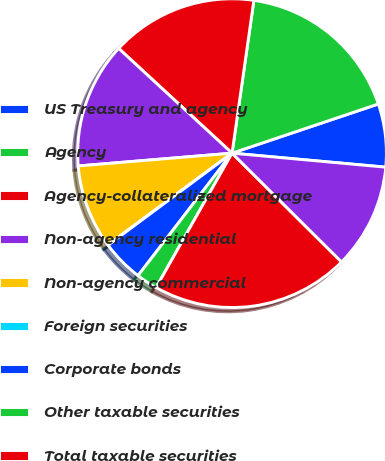<chart> <loc_0><loc_0><loc_500><loc_500><pie_chart><fcel>US Treasury and agency<fcel>Agency<fcel>Agency-collateralized mortgage<fcel>Non-agency residential<fcel>Non-agency commercial<fcel>Foreign securities<fcel>Corporate bonds<fcel>Other taxable securities<fcel>Total taxable securities<fcel>Tax-exempt securities (2)<nl><fcel>6.61%<fcel>17.58%<fcel>15.39%<fcel>13.19%<fcel>8.81%<fcel>0.03%<fcel>4.42%<fcel>2.23%<fcel>20.74%<fcel>11.0%<nl></chart> 